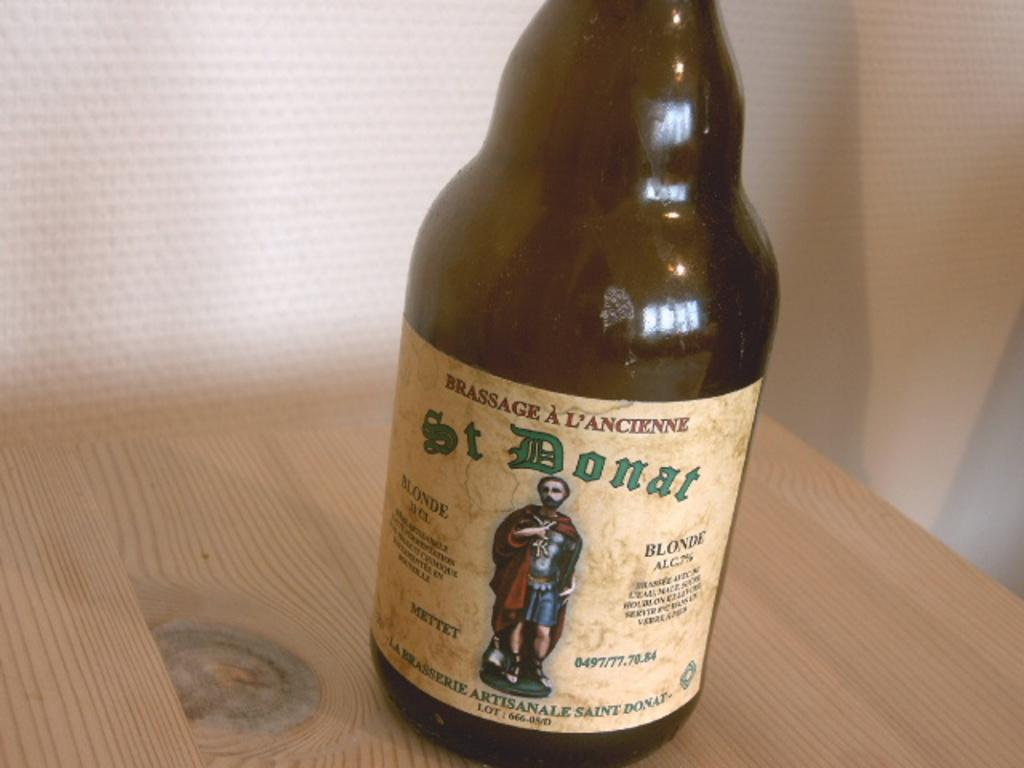<image>
Render a clear and concise summary of the photo. A bottle of St Donat lager sits on a wooden table. 